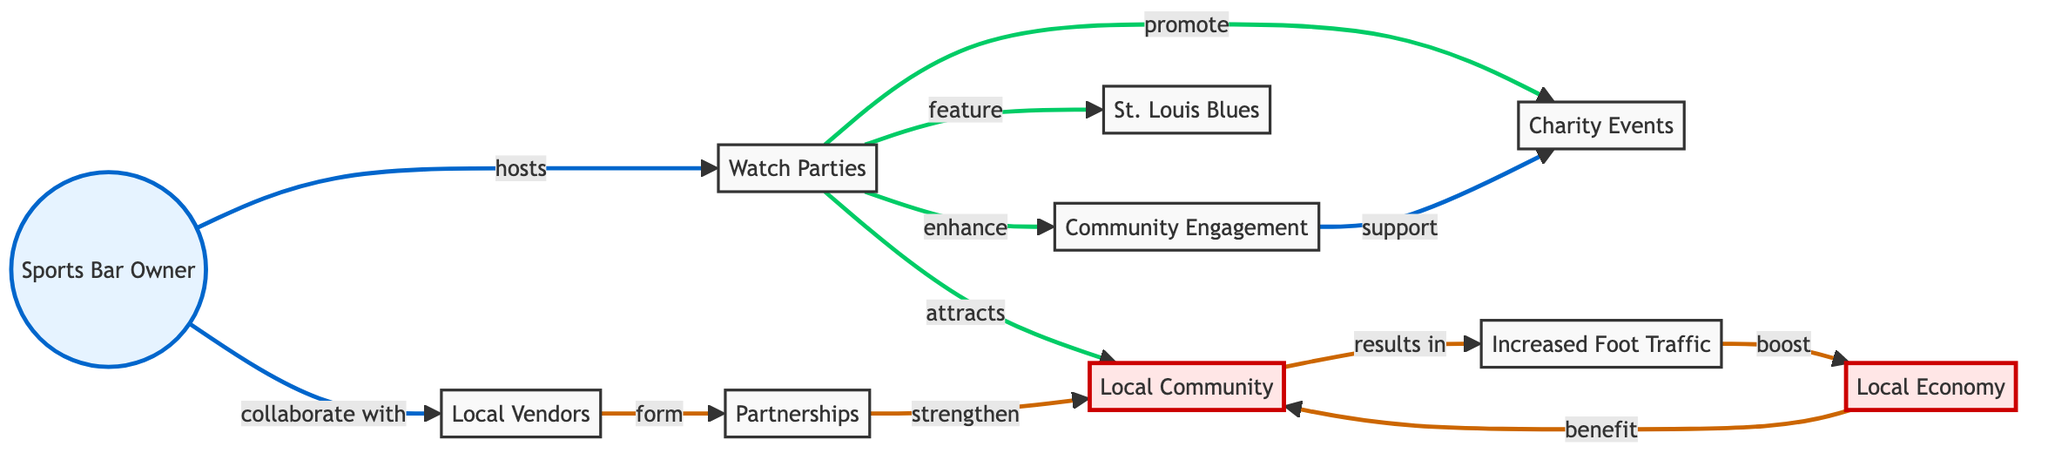What is the main activity hosted by the Sports Bar Owner? The diagram indicates that the Sports Bar Owner hosts "Watch Parties" as the main activity. This is directly connected to the "Sports Bar Owner" node, showing a clear relationship.
Answer: Watch Parties How many main nodes are there in the diagram? By counting the nodes in the diagram, we can identify that there are a total of 10 main nodes representing different aspects of the social impact.
Answer: 10 What is one way that watch parties benefit the local community? The diagram illustrates that watch parties attract the "Local Community," which highlights the direct benefit of increased community engagement.
Answer: Attracts Local Community Which node illustrates the partnership aspect in the diagram? Within the diagram, the "Partnerships" node explicitly connects the "Local Vendors" and "Community Engagement" nodes indicating the collaborative effort.
Answer: Partnerships What directly enhances community engagement according to the diagram? The diagram suggests that the "Watch Parties" directly enhance "Community Engagement," showing a clear link of influence.
Answer: Enhance Community Engagement How do partnerships with local vendors impact the local economy? The diagram outlines that partnerships formed with local vendors strengthen the local community, which subsequently results in boosting the "Local Economy," illustrating a flow of impact through multiple connections.
Answer: Boost Local Economy What role do charity events play in watch parties? According to the diagram, charity events are promoted through watch parties, demonstrating their importance in the overall community engagement strategy.
Answer: Promote Charity Events How does increased foot traffic relate to the local community? The diagram shows that the increased foot traffic is a result of attracting the local community, which benefits local businesses and the economy collectively, revealing an interconnected relationship between these elements.
Answer: Results in Increased Foot Traffic What is the outcome of the watch parties on local vendors? The watch parties facilitate collaboration with local vendors, which leads to the formation of partnerships; thus, the outcome is the creation of these partnerships enhancing community ties.
Answer: Form Partnerships How does "Increased Foot Traffic" relate to the "Local Economy"? The diagram establishes a direct link whereby increased foot traffic directly boosts the local economy, indicating a cause and effect relationship between them.
Answer: Boost Local Economy 